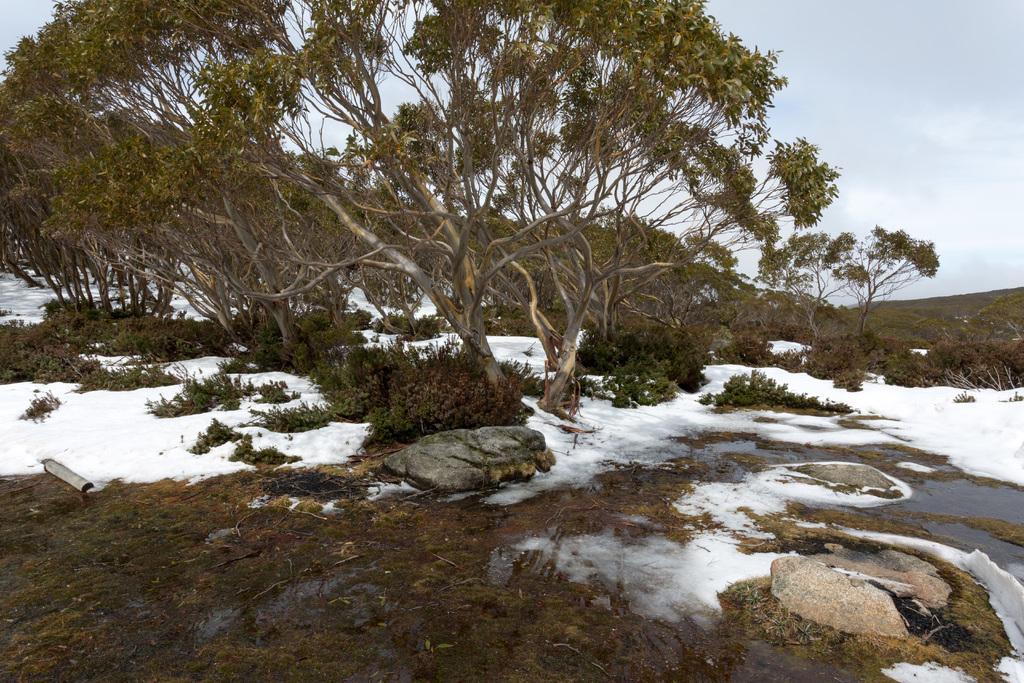Describe this image in one or two sentences. In the foreground of the picture there are stones, snow and water. In the center of the picture there are trees, plants and snow. In the background it is sky, sky is cloudy. 